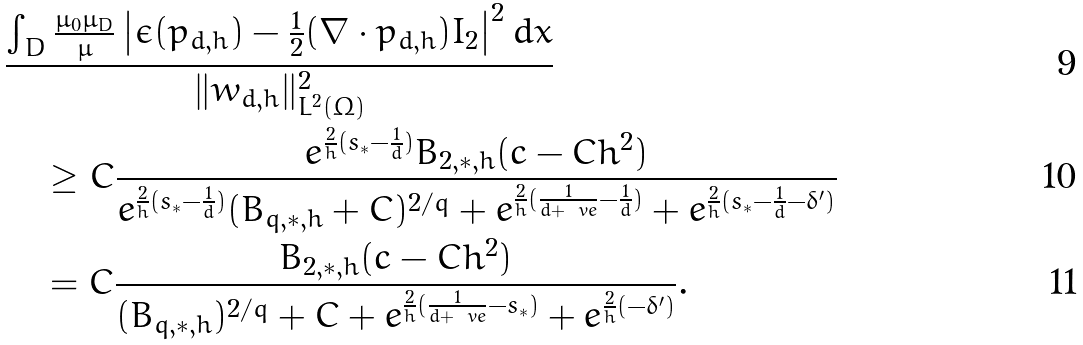Convert formula to latex. <formula><loc_0><loc_0><loc_500><loc_500>& \frac { \int _ { D } \frac { \mu _ { 0 } \mu _ { D } } { \mu } \left | \epsilon ( p _ { d , h } ) - \frac { 1 } { 2 } ( \nabla \cdot p _ { d , h } ) I _ { 2 } \right | ^ { 2 } d x } { \| w _ { d , h } \| ^ { 2 } _ { L ^ { 2 } ( \Omega ) } } \\ & \quad \geq C \frac { e ^ { \frac { 2 } { h } ( s _ { * } - \frac { 1 } { d } ) } B _ { 2 , * , h } ( c - C h ^ { 2 } ) } { e ^ { \frac { 2 } { h } ( s _ { * } - \frac { 1 } { d } ) } ( B _ { q , * , h } + C ) ^ { 2 / q } + e ^ { \frac { 2 } { h } ( \frac { 1 } { d + \ v e } - \frac { 1 } { d } ) } + e ^ { \frac { 2 } { h } ( s _ { * } - \frac { 1 } { d } - \delta ^ { \prime } ) } } \\ & \quad = C \frac { B _ { 2 , * , h } ( c - C h ^ { 2 } ) } { ( B _ { q , * , h } ) ^ { 2 / q } + C + e ^ { \frac { 2 } { h } ( \frac { 1 } { d + \ v e } - s _ { * } ) } + e ^ { \frac { 2 } { h } ( - \delta ^ { \prime } ) } } .</formula> 